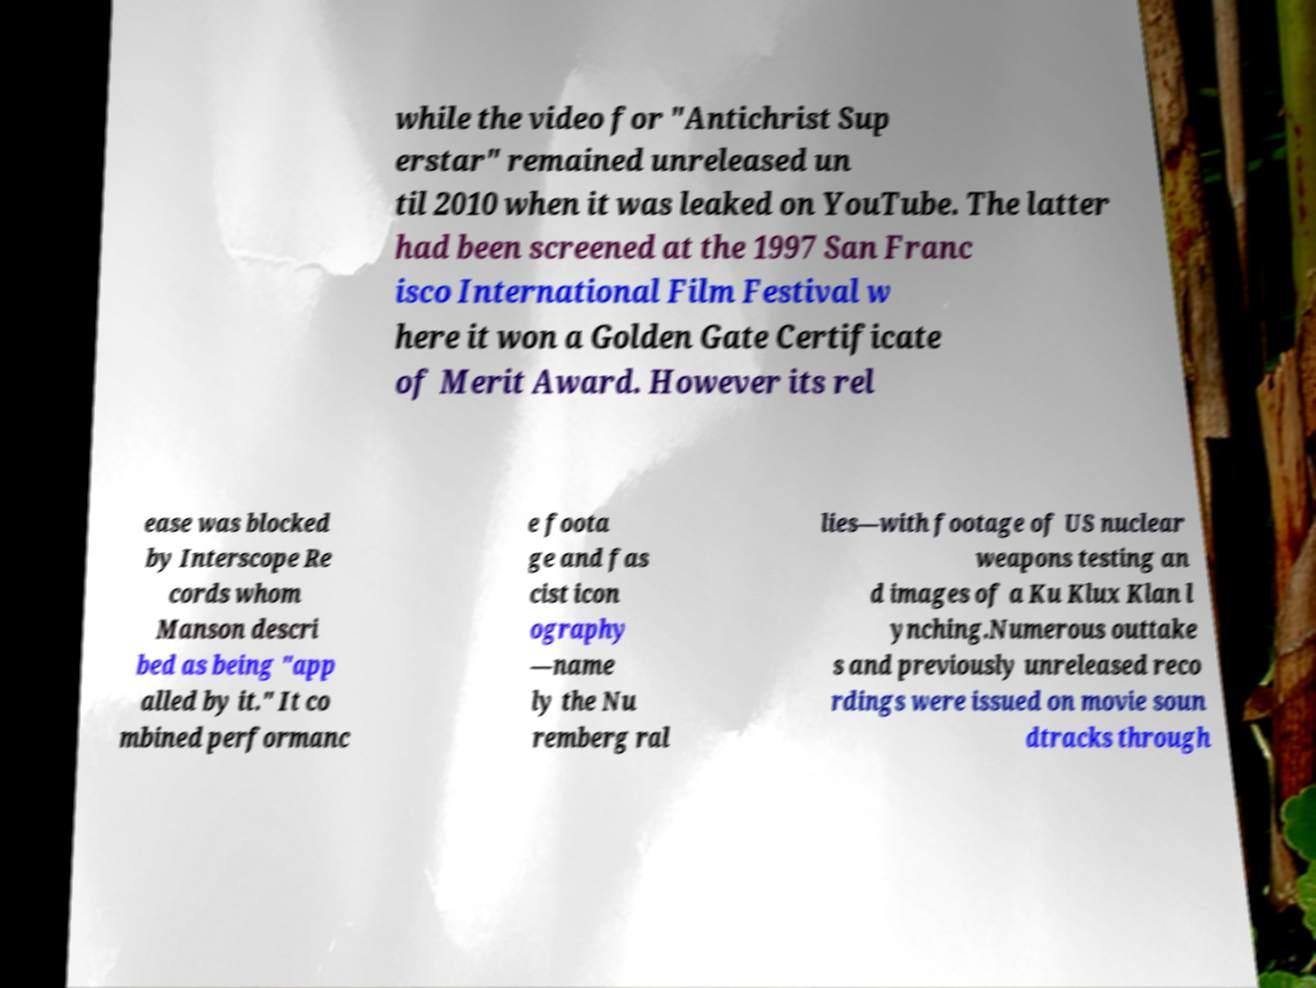Can you accurately transcribe the text from the provided image for me? while the video for "Antichrist Sup erstar" remained unreleased un til 2010 when it was leaked on YouTube. The latter had been screened at the 1997 San Franc isco International Film Festival w here it won a Golden Gate Certificate of Merit Award. However its rel ease was blocked by Interscope Re cords whom Manson descri bed as being "app alled by it." It co mbined performanc e foota ge and fas cist icon ography —name ly the Nu remberg ral lies—with footage of US nuclear weapons testing an d images of a Ku Klux Klan l ynching.Numerous outtake s and previously unreleased reco rdings were issued on movie soun dtracks through 